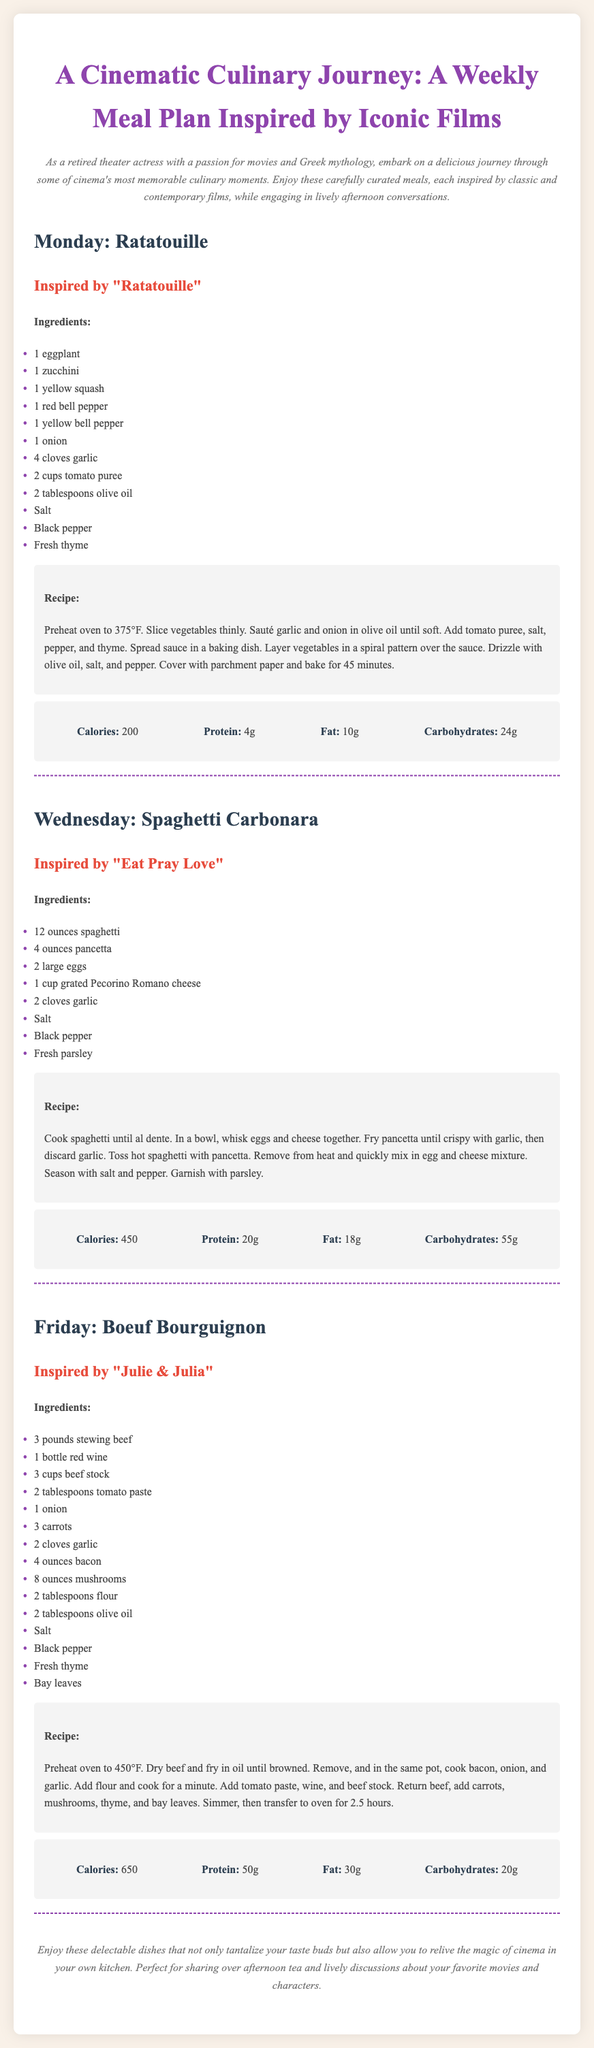What dish is served on Monday? The document specifies "Ratatouille" as the dish for Monday.
Answer: Ratatouille What film inspires the Spaghetti Carbonara recipe? The document states that the Spaghetti Carbonara is inspired by the film "Eat Pray Love."
Answer: Eat Pray Love How many ounces of pancetta are needed for Spaghetti Carbonara? The recipe lists 4 ounces of pancetta as an ingredient for Spaghetti Carbonara.
Answer: 4 ounces What is the total cooking time for Boeuf Bourguignon? The document indicates that Boeuf Bourguignon is simmered and then cooked in the oven for 2.5 hours, which is its total cooking time.
Answer: 2.5 hours What is the primary liquid ingredient for the Boeuf Bourguignon? The main liquid ingredient mentioned for Boeuf Bourguignon is red wine.
Answer: Red wine What is the calorie count for the Ratatouille dish? According to the document, Ratatouille contains 200 calories.
Answer: 200 How many meals are included in the weekly meal plan? The document includes three meals for the week.
Answer: Three What is the main vegetable used in the Ratatouille dish? The primary vegetable used in Ratatouille is eggplant.
Answer: Eggplant What type of cheese is used in Spaghetti Carbonara? The document lists Pecorino Romano cheese as the type of cheese used.
Answer: Pecorino Romano cheese 